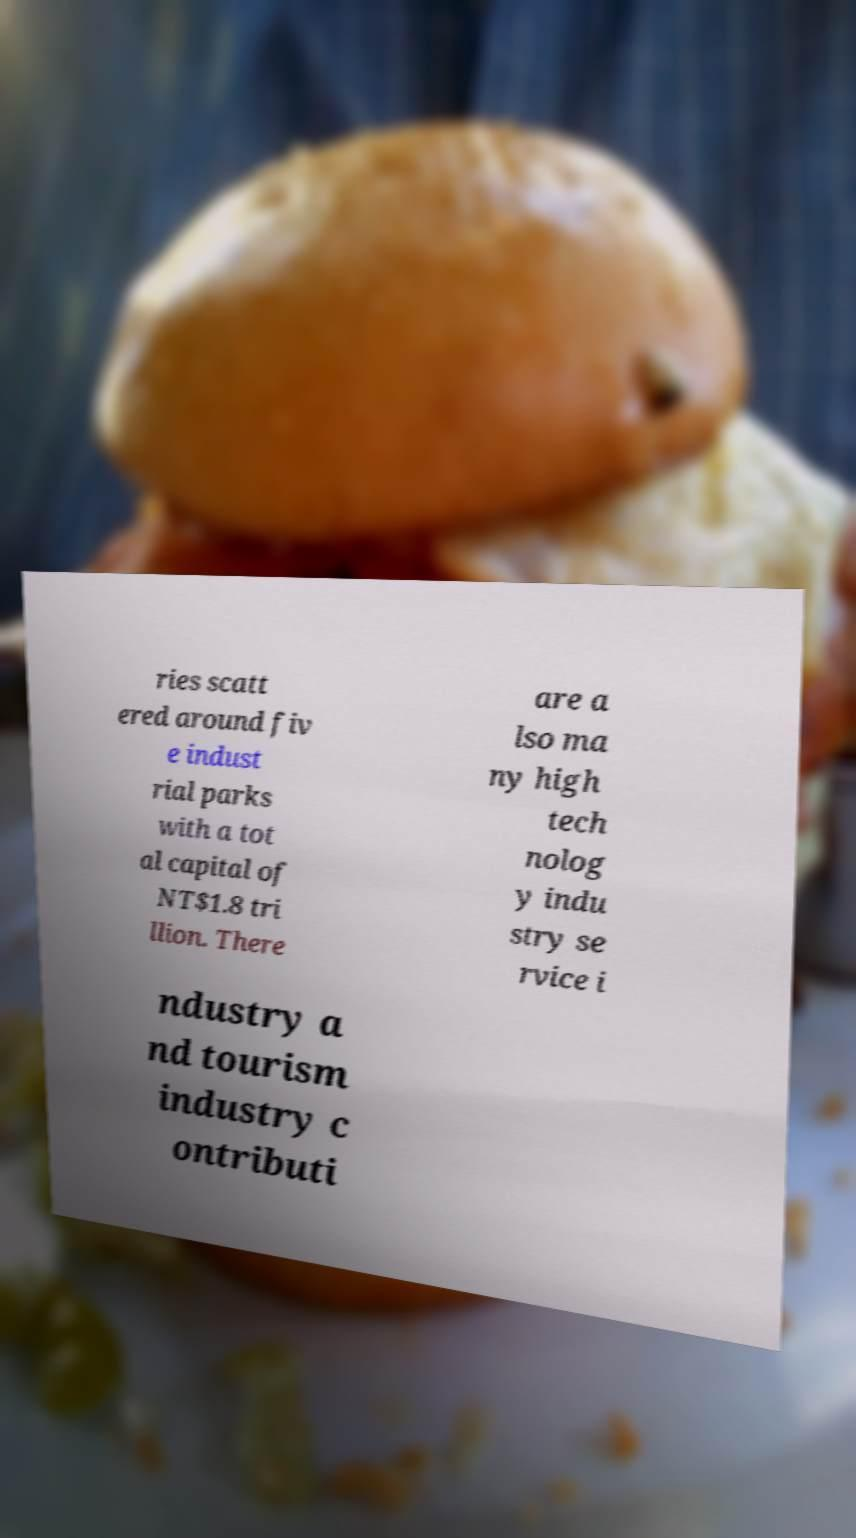Could you extract and type out the text from this image? ries scatt ered around fiv e indust rial parks with a tot al capital of NT$1.8 tri llion. There are a lso ma ny high tech nolog y indu stry se rvice i ndustry a nd tourism industry c ontributi 